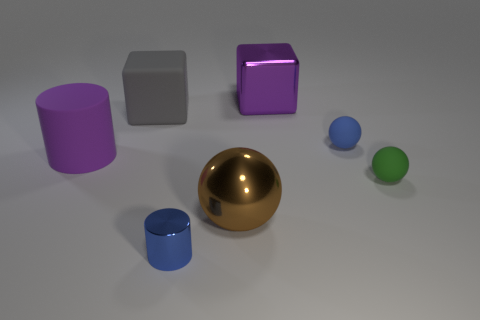Subtract all matte balls. How many balls are left? 1 Add 2 tiny green spheres. How many objects exist? 9 Subtract all blue spheres. How many spheres are left? 2 Add 2 tiny yellow objects. How many tiny yellow objects exist? 2 Subtract 1 purple cylinders. How many objects are left? 6 Subtract all spheres. How many objects are left? 4 Subtract all blue cylinders. Subtract all gray cubes. How many cylinders are left? 1 Subtract all brown metallic spheres. Subtract all tiny blue balls. How many objects are left? 5 Add 7 rubber spheres. How many rubber spheres are left? 9 